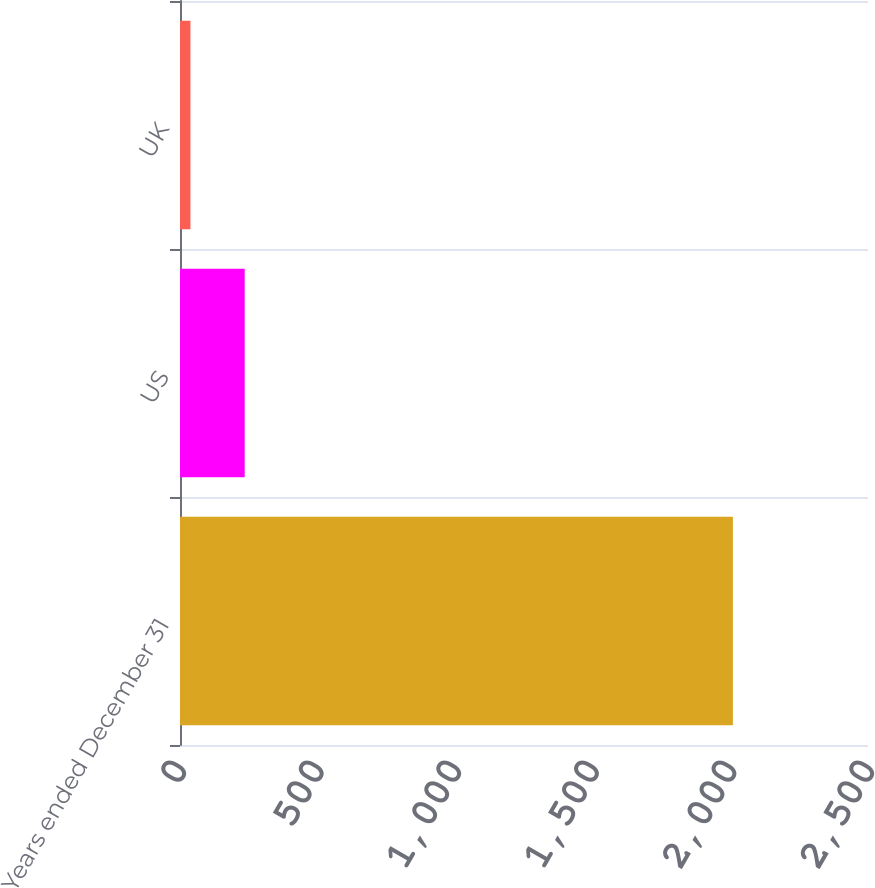<chart> <loc_0><loc_0><loc_500><loc_500><bar_chart><fcel>Years ended December 31<fcel>US<fcel>UK<nl><fcel>2009<fcel>235.1<fcel>38<nl></chart> 